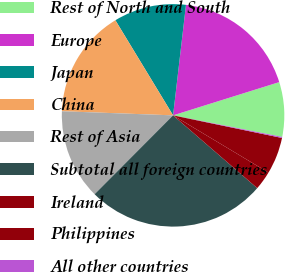<chart> <loc_0><loc_0><loc_500><loc_500><pie_chart><fcel>Rest of North and South<fcel>Europe<fcel>Japan<fcel>China<fcel>Rest of Asia<fcel>Subtotal all foreign countries<fcel>Ireland<fcel>Philippines<fcel>All other countries<nl><fcel>7.94%<fcel>18.32%<fcel>10.53%<fcel>15.73%<fcel>13.13%<fcel>26.11%<fcel>2.75%<fcel>5.34%<fcel>0.15%<nl></chart> 